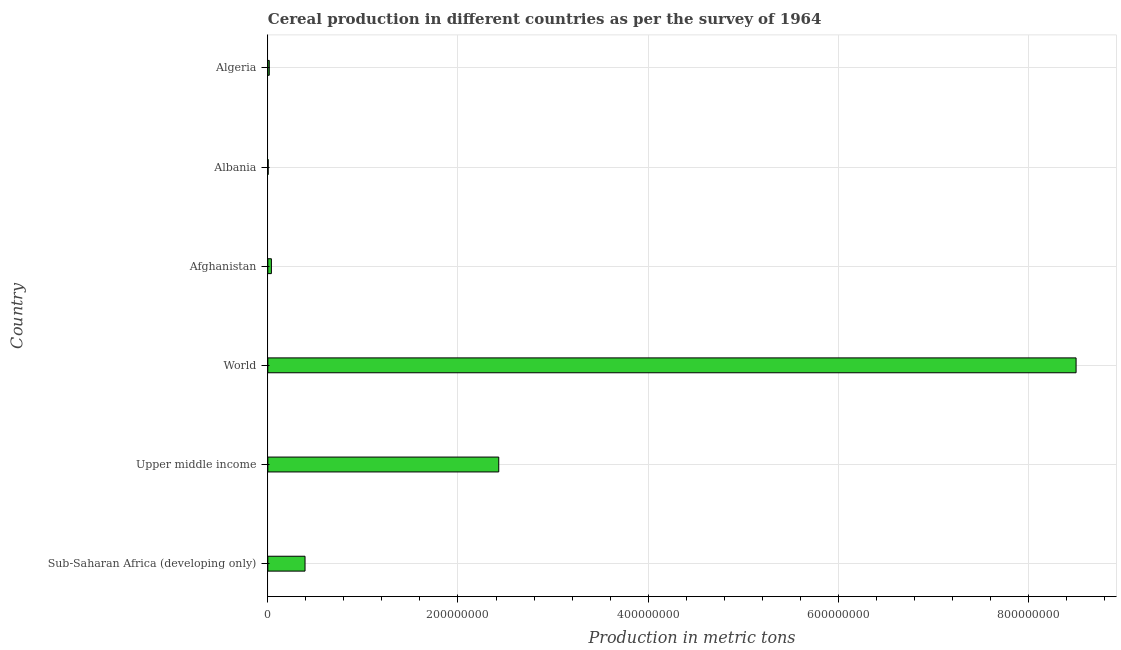Does the graph contain any zero values?
Your response must be concise. No. What is the title of the graph?
Ensure brevity in your answer.  Cereal production in different countries as per the survey of 1964. What is the label or title of the X-axis?
Offer a very short reply. Production in metric tons. What is the cereal production in World?
Give a very brief answer. 8.50e+08. Across all countries, what is the maximum cereal production?
Your answer should be compact. 8.50e+08. Across all countries, what is the minimum cereal production?
Your answer should be very brief. 3.50e+05. In which country was the cereal production maximum?
Your answer should be very brief. World. In which country was the cereal production minimum?
Ensure brevity in your answer.  Albania. What is the sum of the cereal production?
Your response must be concise. 1.14e+09. What is the difference between the cereal production in Sub-Saharan Africa (developing only) and Upper middle income?
Give a very brief answer. -2.04e+08. What is the average cereal production per country?
Keep it short and to the point. 1.90e+08. What is the median cereal production?
Ensure brevity in your answer.  2.14e+07. What is the ratio of the cereal production in Afghanistan to that in Algeria?
Your answer should be compact. 2.51. Is the cereal production in Albania less than that in World?
Provide a succinct answer. Yes. What is the difference between the highest and the second highest cereal production?
Offer a very short reply. 6.07e+08. Is the sum of the cereal production in Afghanistan and Upper middle income greater than the maximum cereal production across all countries?
Your response must be concise. No. What is the difference between the highest and the lowest cereal production?
Offer a terse response. 8.50e+08. In how many countries, is the cereal production greater than the average cereal production taken over all countries?
Your answer should be very brief. 2. How many bars are there?
Make the answer very short. 6. How many countries are there in the graph?
Offer a very short reply. 6. Are the values on the major ticks of X-axis written in scientific E-notation?
Ensure brevity in your answer.  No. What is the Production in metric tons in Sub-Saharan Africa (developing only)?
Your response must be concise. 3.91e+07. What is the Production in metric tons in Upper middle income?
Offer a very short reply. 2.43e+08. What is the Production in metric tons of World?
Give a very brief answer. 8.50e+08. What is the Production in metric tons in Afghanistan?
Offer a terse response. 3.73e+06. What is the Production in metric tons in Albania?
Offer a terse response. 3.50e+05. What is the Production in metric tons in Algeria?
Make the answer very short. 1.49e+06. What is the difference between the Production in metric tons in Sub-Saharan Africa (developing only) and Upper middle income?
Provide a succinct answer. -2.04e+08. What is the difference between the Production in metric tons in Sub-Saharan Africa (developing only) and World?
Offer a very short reply. -8.11e+08. What is the difference between the Production in metric tons in Sub-Saharan Africa (developing only) and Afghanistan?
Provide a short and direct response. 3.54e+07. What is the difference between the Production in metric tons in Sub-Saharan Africa (developing only) and Albania?
Make the answer very short. 3.88e+07. What is the difference between the Production in metric tons in Sub-Saharan Africa (developing only) and Algeria?
Your answer should be very brief. 3.76e+07. What is the difference between the Production in metric tons in Upper middle income and World?
Your response must be concise. -6.07e+08. What is the difference between the Production in metric tons in Upper middle income and Afghanistan?
Ensure brevity in your answer.  2.39e+08. What is the difference between the Production in metric tons in Upper middle income and Albania?
Offer a very short reply. 2.43e+08. What is the difference between the Production in metric tons in Upper middle income and Algeria?
Provide a succinct answer. 2.41e+08. What is the difference between the Production in metric tons in World and Afghanistan?
Give a very brief answer. 8.46e+08. What is the difference between the Production in metric tons in World and Albania?
Your answer should be compact. 8.50e+08. What is the difference between the Production in metric tons in World and Algeria?
Your answer should be compact. 8.49e+08. What is the difference between the Production in metric tons in Afghanistan and Albania?
Make the answer very short. 3.38e+06. What is the difference between the Production in metric tons in Afghanistan and Algeria?
Your answer should be compact. 2.24e+06. What is the difference between the Production in metric tons in Albania and Algeria?
Offer a very short reply. -1.14e+06. What is the ratio of the Production in metric tons in Sub-Saharan Africa (developing only) to that in Upper middle income?
Give a very brief answer. 0.16. What is the ratio of the Production in metric tons in Sub-Saharan Africa (developing only) to that in World?
Your response must be concise. 0.05. What is the ratio of the Production in metric tons in Sub-Saharan Africa (developing only) to that in Afghanistan?
Your answer should be compact. 10.48. What is the ratio of the Production in metric tons in Sub-Saharan Africa (developing only) to that in Albania?
Provide a succinct answer. 111.71. What is the ratio of the Production in metric tons in Sub-Saharan Africa (developing only) to that in Algeria?
Offer a terse response. 26.3. What is the ratio of the Production in metric tons in Upper middle income to that in World?
Provide a succinct answer. 0.29. What is the ratio of the Production in metric tons in Upper middle income to that in Afghanistan?
Provide a short and direct response. 65.08. What is the ratio of the Production in metric tons in Upper middle income to that in Albania?
Provide a short and direct response. 693.66. What is the ratio of the Production in metric tons in Upper middle income to that in Algeria?
Provide a succinct answer. 163.28. What is the ratio of the Production in metric tons in World to that in Afghanistan?
Your response must be concise. 227.8. What is the ratio of the Production in metric tons in World to that in Albania?
Offer a terse response. 2427.98. What is the ratio of the Production in metric tons in World to that in Algeria?
Your answer should be compact. 571.52. What is the ratio of the Production in metric tons in Afghanistan to that in Albania?
Your answer should be very brief. 10.66. What is the ratio of the Production in metric tons in Afghanistan to that in Algeria?
Your response must be concise. 2.51. What is the ratio of the Production in metric tons in Albania to that in Algeria?
Provide a short and direct response. 0.23. 